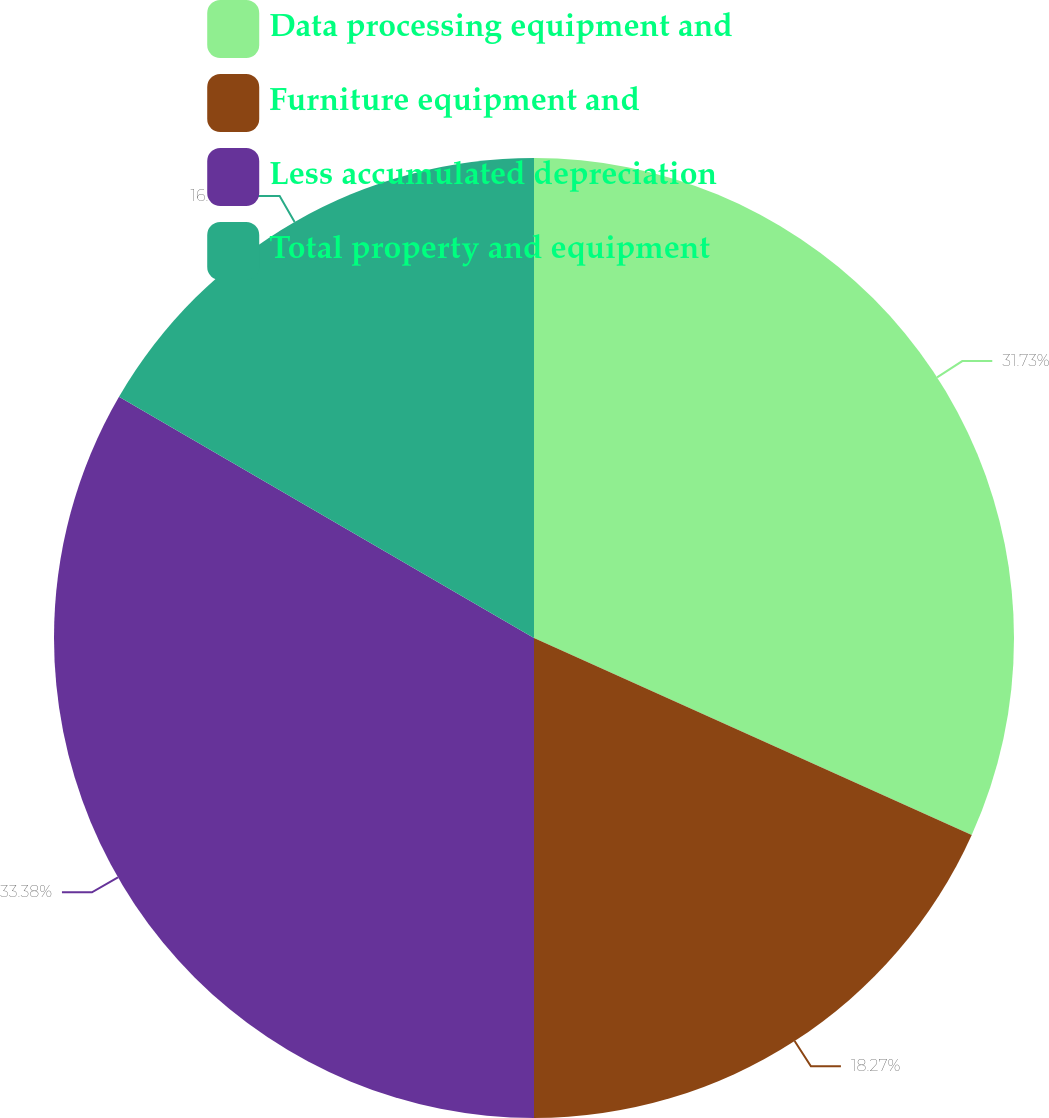<chart> <loc_0><loc_0><loc_500><loc_500><pie_chart><fcel>Data processing equipment and<fcel>Furniture equipment and<fcel>Less accumulated depreciation<fcel>Total property and equipment<nl><fcel>31.73%<fcel>18.27%<fcel>33.38%<fcel>16.62%<nl></chart> 